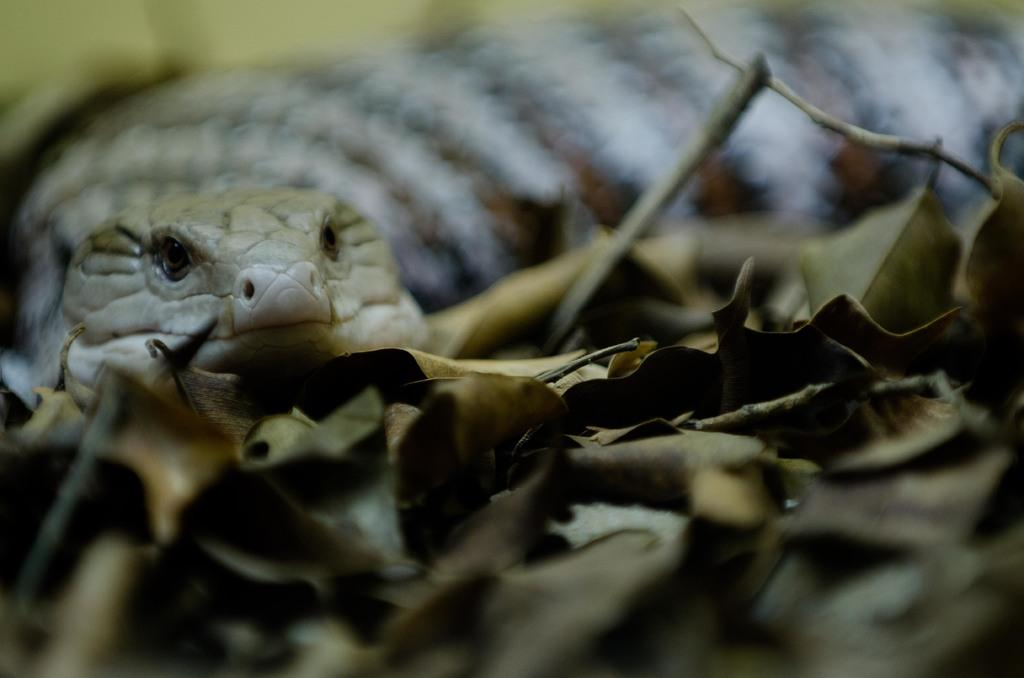What animal is present in the image? There is a snake in the image. Where is the snake located? The snake is on the land. What can be seen around the snake in the image? There are dried leaves on the snake or nearby. How many boys are playing with the snake in the image? There are no boys present in the image; it only features a snake and dried leaves. 